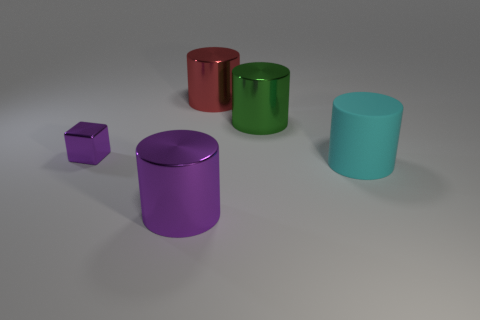The other object that is the same color as the tiny object is what size?
Offer a very short reply. Large. Does the metal block have the same color as the metallic thing in front of the large cyan cylinder?
Offer a very short reply. Yes. Is there any other thing that has the same material as the big cyan cylinder?
Offer a terse response. No. What number of other things are the same size as the purple metallic cylinder?
Offer a terse response. 3. How many things are cyan matte cylinders or big cylinders to the right of the purple metallic cylinder?
Your answer should be compact. 3. Are there fewer tiny cyan metal balls than cubes?
Your response must be concise. Yes. The metallic cylinder that is in front of the large thing on the right side of the green metal object is what color?
Your answer should be compact. Purple. What material is the big green thing that is the same shape as the big red thing?
Make the answer very short. Metal. What number of metallic objects are large cylinders or purple cylinders?
Your response must be concise. 3. Do the purple object that is in front of the small purple metallic block and the large cyan cylinder that is to the right of the big red shiny thing have the same material?
Make the answer very short. No. 